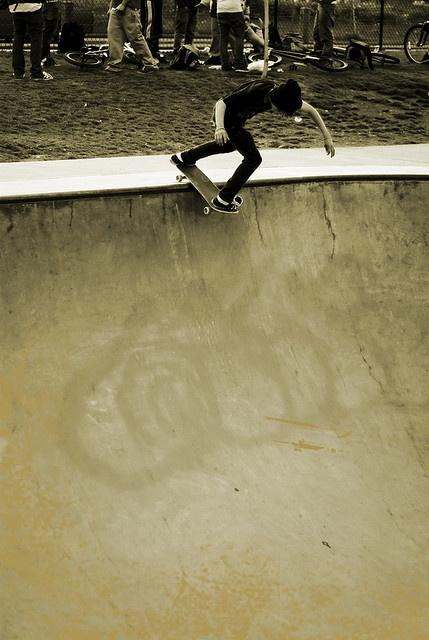Describe the objects in this image and their specific colors. I can see people in black, tan, darkgreen, and gray tones, people in black, tan, and darkgreen tones, people in black, darkgreen, and olive tones, people in black, beige, and tan tones, and people in black, darkgreen, gray, and tan tones in this image. 